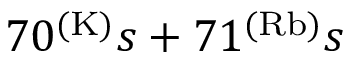Convert formula to latex. <formula><loc_0><loc_0><loc_500><loc_500>7 0 ^ { ( K ) } s + 7 1 ^ { ( R b ) } s</formula> 